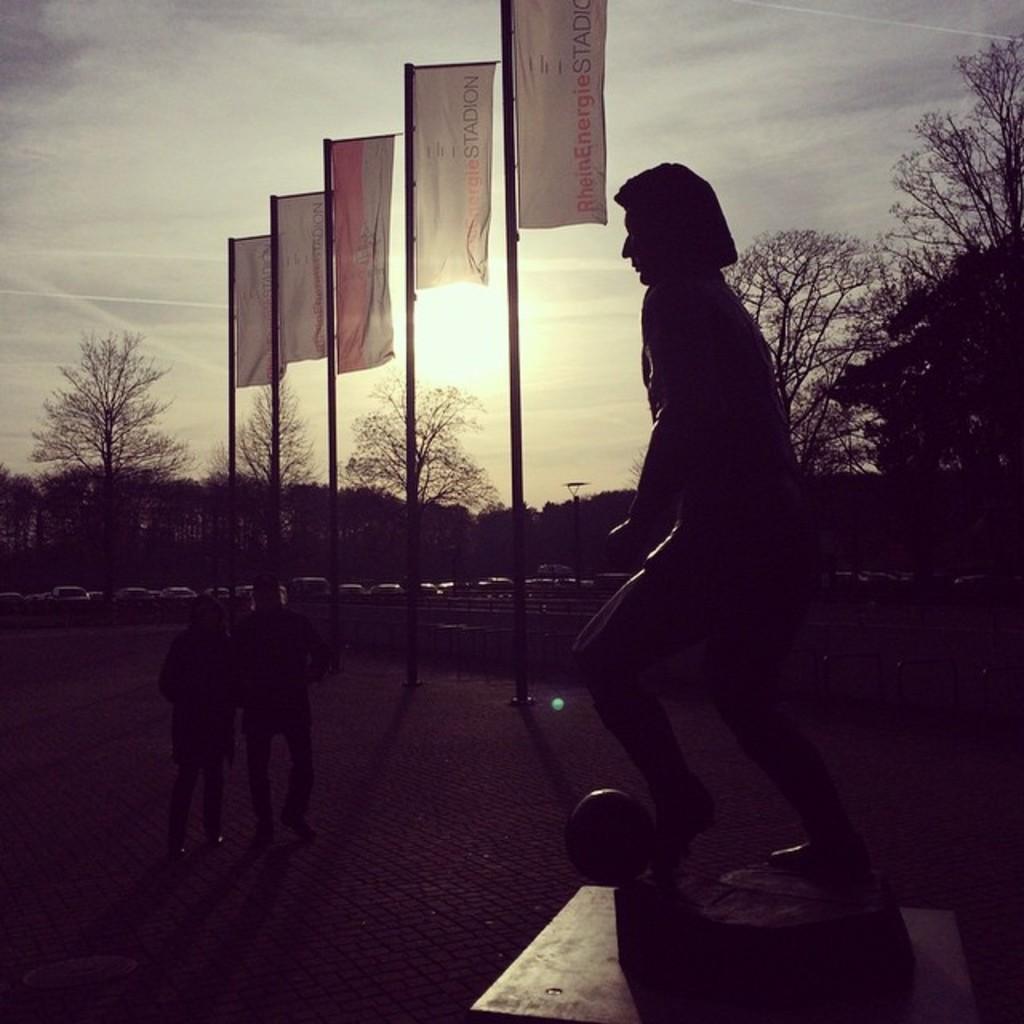In one or two sentences, can you explain what this image depicts? In this picture I can see a statue in front and behind it I see the path on which I see 2 persons and few poles on which there are flags. In the background I can see number of trees, vehicles and the sky. 